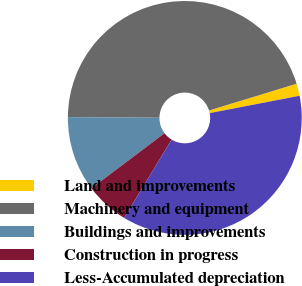Convert chart. <chart><loc_0><loc_0><loc_500><loc_500><pie_chart><fcel>Land and improvements<fcel>Machinery and equipment<fcel>Buildings and improvements<fcel>Construction in progress<fcel>Less-Accumulated depreciation<nl><fcel>1.69%<fcel>45.16%<fcel>10.39%<fcel>6.04%<fcel>36.72%<nl></chart> 